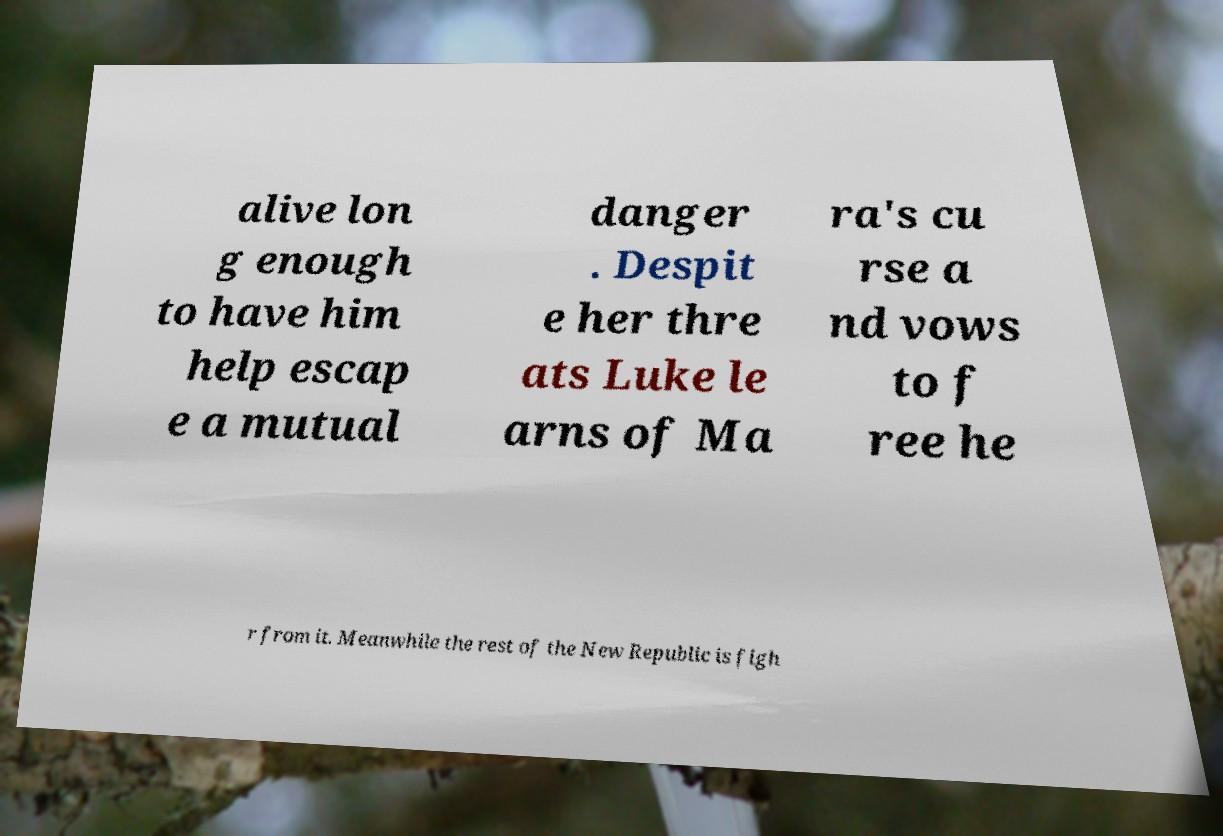Please read and relay the text visible in this image. What does it say? alive lon g enough to have him help escap e a mutual danger . Despit e her thre ats Luke le arns of Ma ra's cu rse a nd vows to f ree he r from it. Meanwhile the rest of the New Republic is figh 